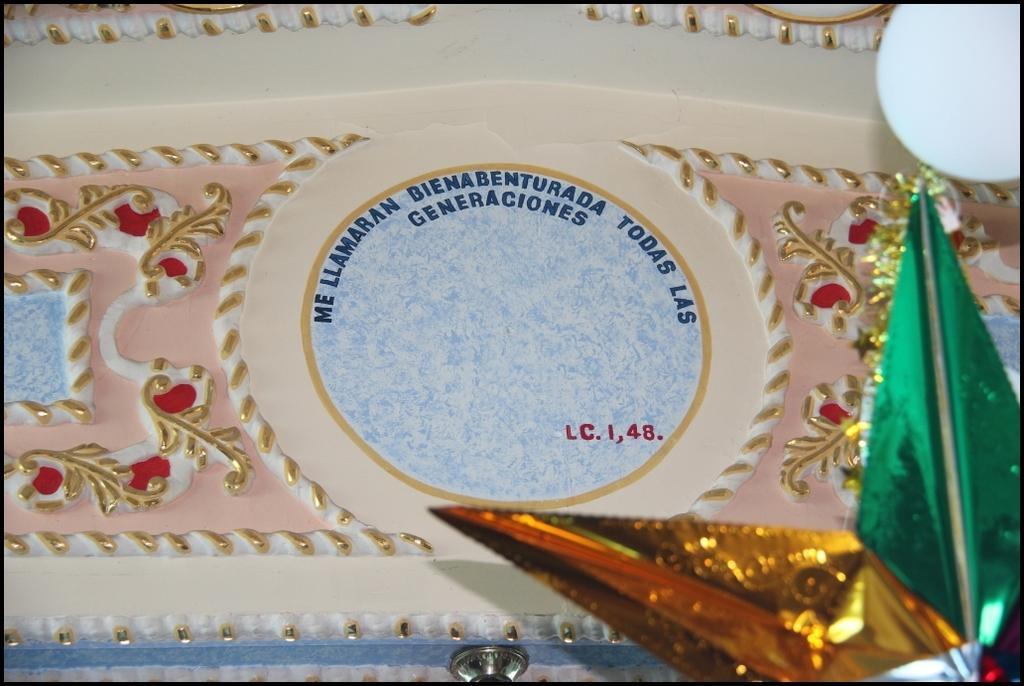Can you describe this image briefly? In this image we can see some text and design on the wall and on the bottom right corner of the image there is a star. 